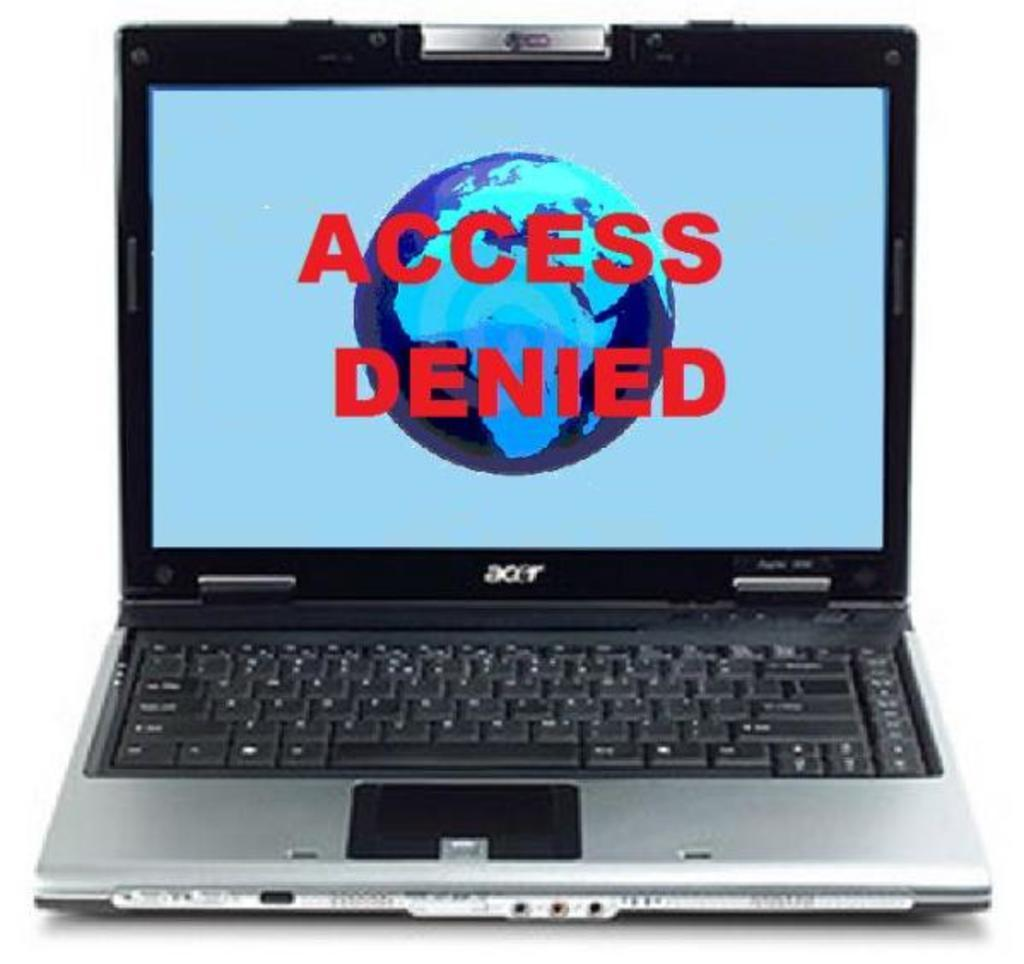<image>
Share a concise interpretation of the image provided. A laptop with its screen opened saying access denied. 